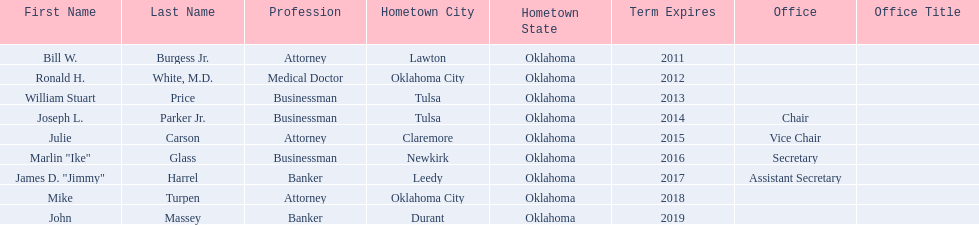Who are the businessmen? Bill W. Burgess Jr., Ronald H. White, M.D., William Stuart Price, Joseph L. Parker Jr., Julie Carson, Marlin "Ike" Glass, James D. "Jimmy" Harrel, Mike Turpen, John Massey. Which were born in tulsa? William Stuart Price, Joseph L. Parker Jr. Of these, which one was other than william stuart price? Joseph L. Parker Jr. 